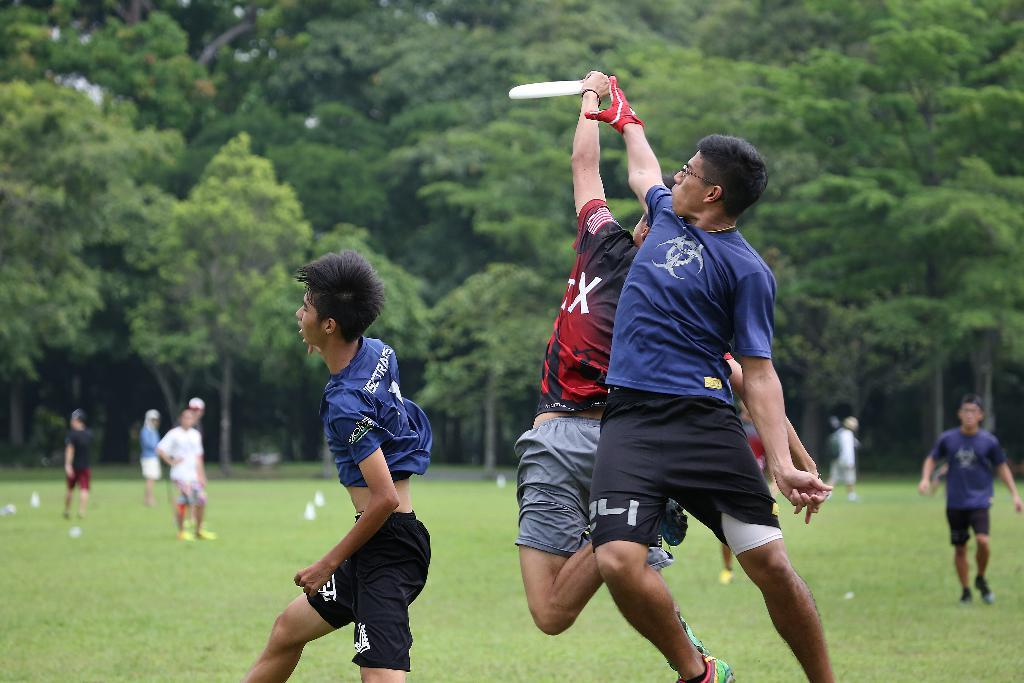<image>
Give a short and clear explanation of the subsequent image. a person in red wearing a shirt with an X jumps for a Frisbee 